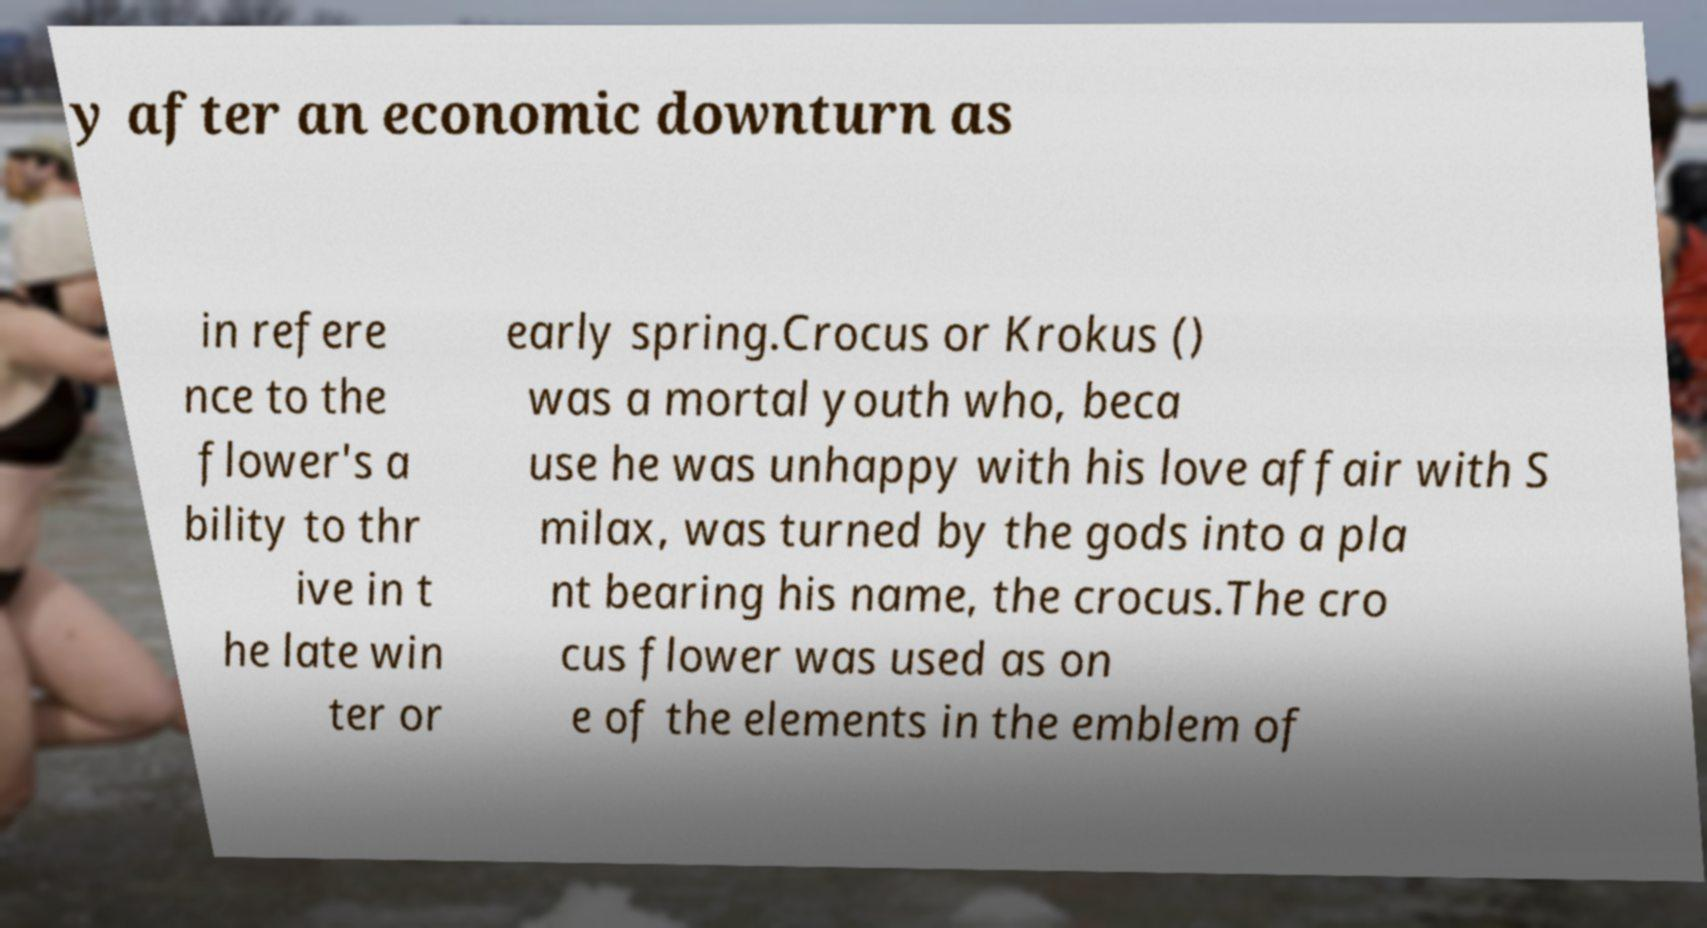Please identify and transcribe the text found in this image. y after an economic downturn as in refere nce to the flower's a bility to thr ive in t he late win ter or early spring.Crocus or Krokus () was a mortal youth who, beca use he was unhappy with his love affair with S milax, was turned by the gods into a pla nt bearing his name, the crocus.The cro cus flower was used as on e of the elements in the emblem of 